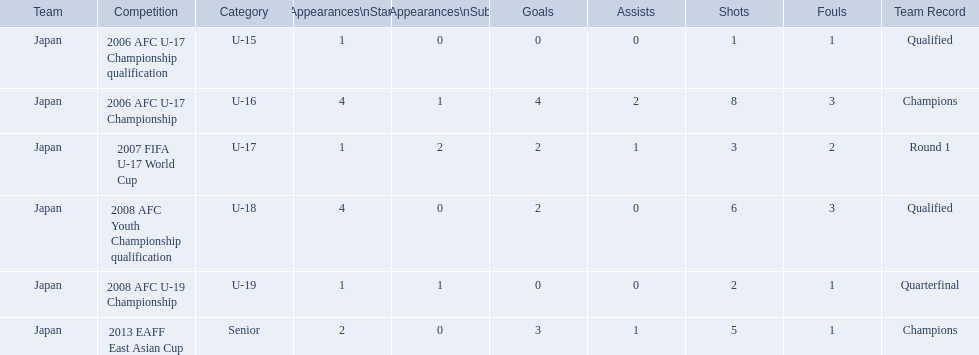What was the team record in 2006? Round 1. What competition did this belong too? 2006 AFC U-17 Championship. 